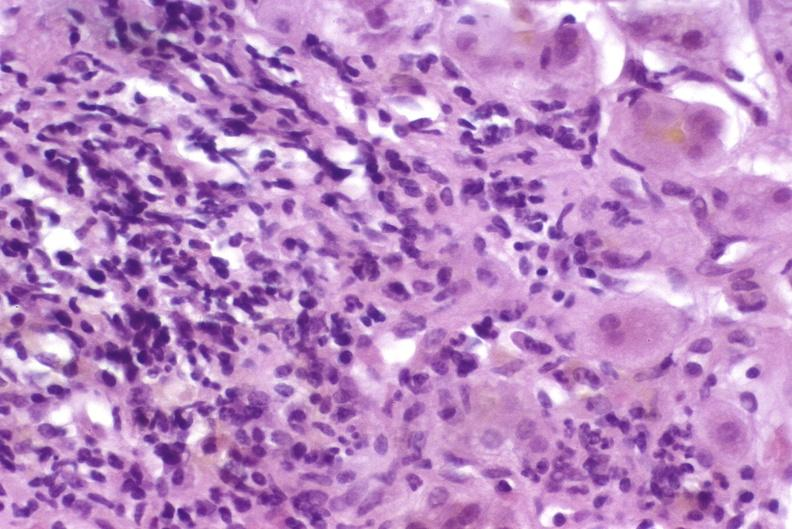does histiocyte show autoimmune hepatitis?
Answer the question using a single word or phrase. No 